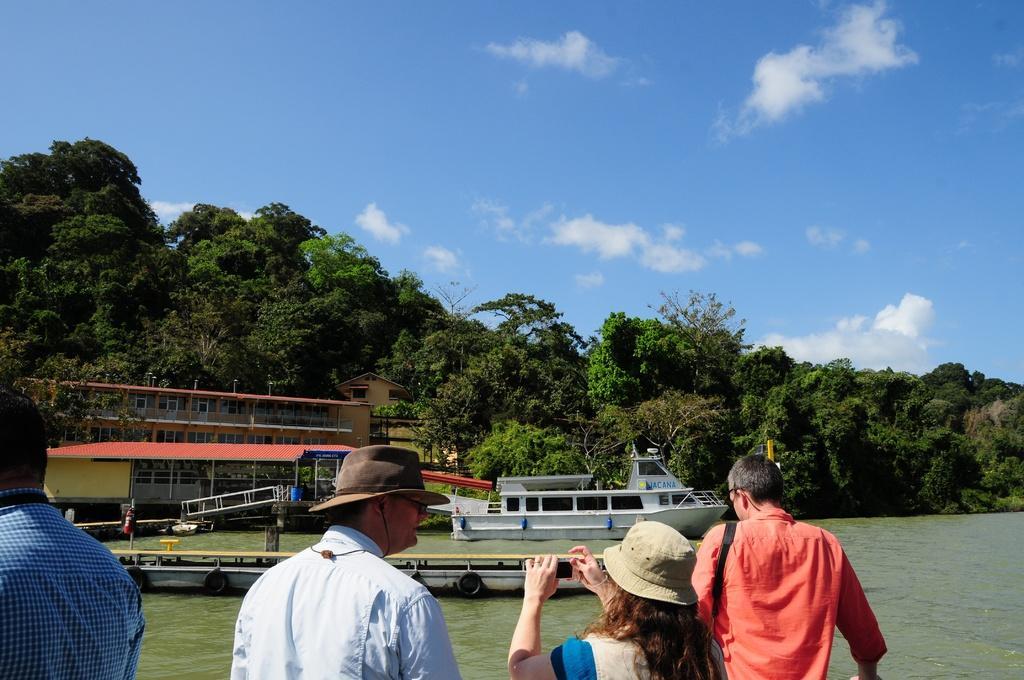In one or two sentences, can you explain what this image depicts? This picture describes about group of people, in the middle of the image we can see a woman, she is holding a camera and she wore a cap, in front of them we can see few boats in the water, in the background we can find few houses and trees. 